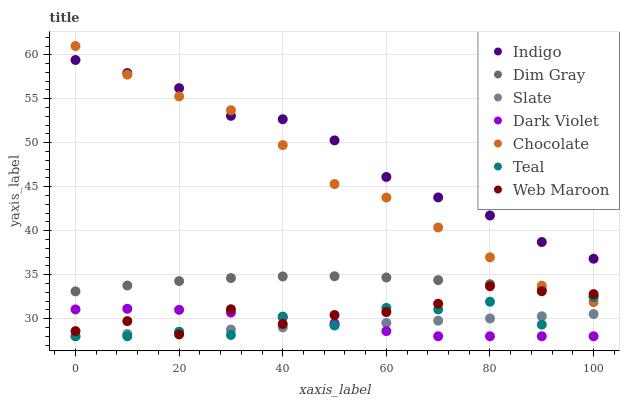Does Slate have the minimum area under the curve?
Answer yes or no. Yes. Does Indigo have the maximum area under the curve?
Answer yes or no. Yes. Does Indigo have the minimum area under the curve?
Answer yes or no. No. Does Slate have the maximum area under the curve?
Answer yes or no. No. Is Slate the smoothest?
Answer yes or no. Yes. Is Teal the roughest?
Answer yes or no. Yes. Is Indigo the smoothest?
Answer yes or no. No. Is Indigo the roughest?
Answer yes or no. No. Does Slate have the lowest value?
Answer yes or no. Yes. Does Indigo have the lowest value?
Answer yes or no. No. Does Chocolate have the highest value?
Answer yes or no. Yes. Does Indigo have the highest value?
Answer yes or no. No. Is Slate less than Chocolate?
Answer yes or no. Yes. Is Indigo greater than Teal?
Answer yes or no. Yes. Does Teal intersect Slate?
Answer yes or no. Yes. Is Teal less than Slate?
Answer yes or no. No. Is Teal greater than Slate?
Answer yes or no. No. Does Slate intersect Chocolate?
Answer yes or no. No. 